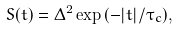Convert formula to latex. <formula><loc_0><loc_0><loc_500><loc_500>S ( t ) = \Delta ^ { 2 } \exp { \left ( - | t | / \tau _ { c } \right ) } ,</formula> 